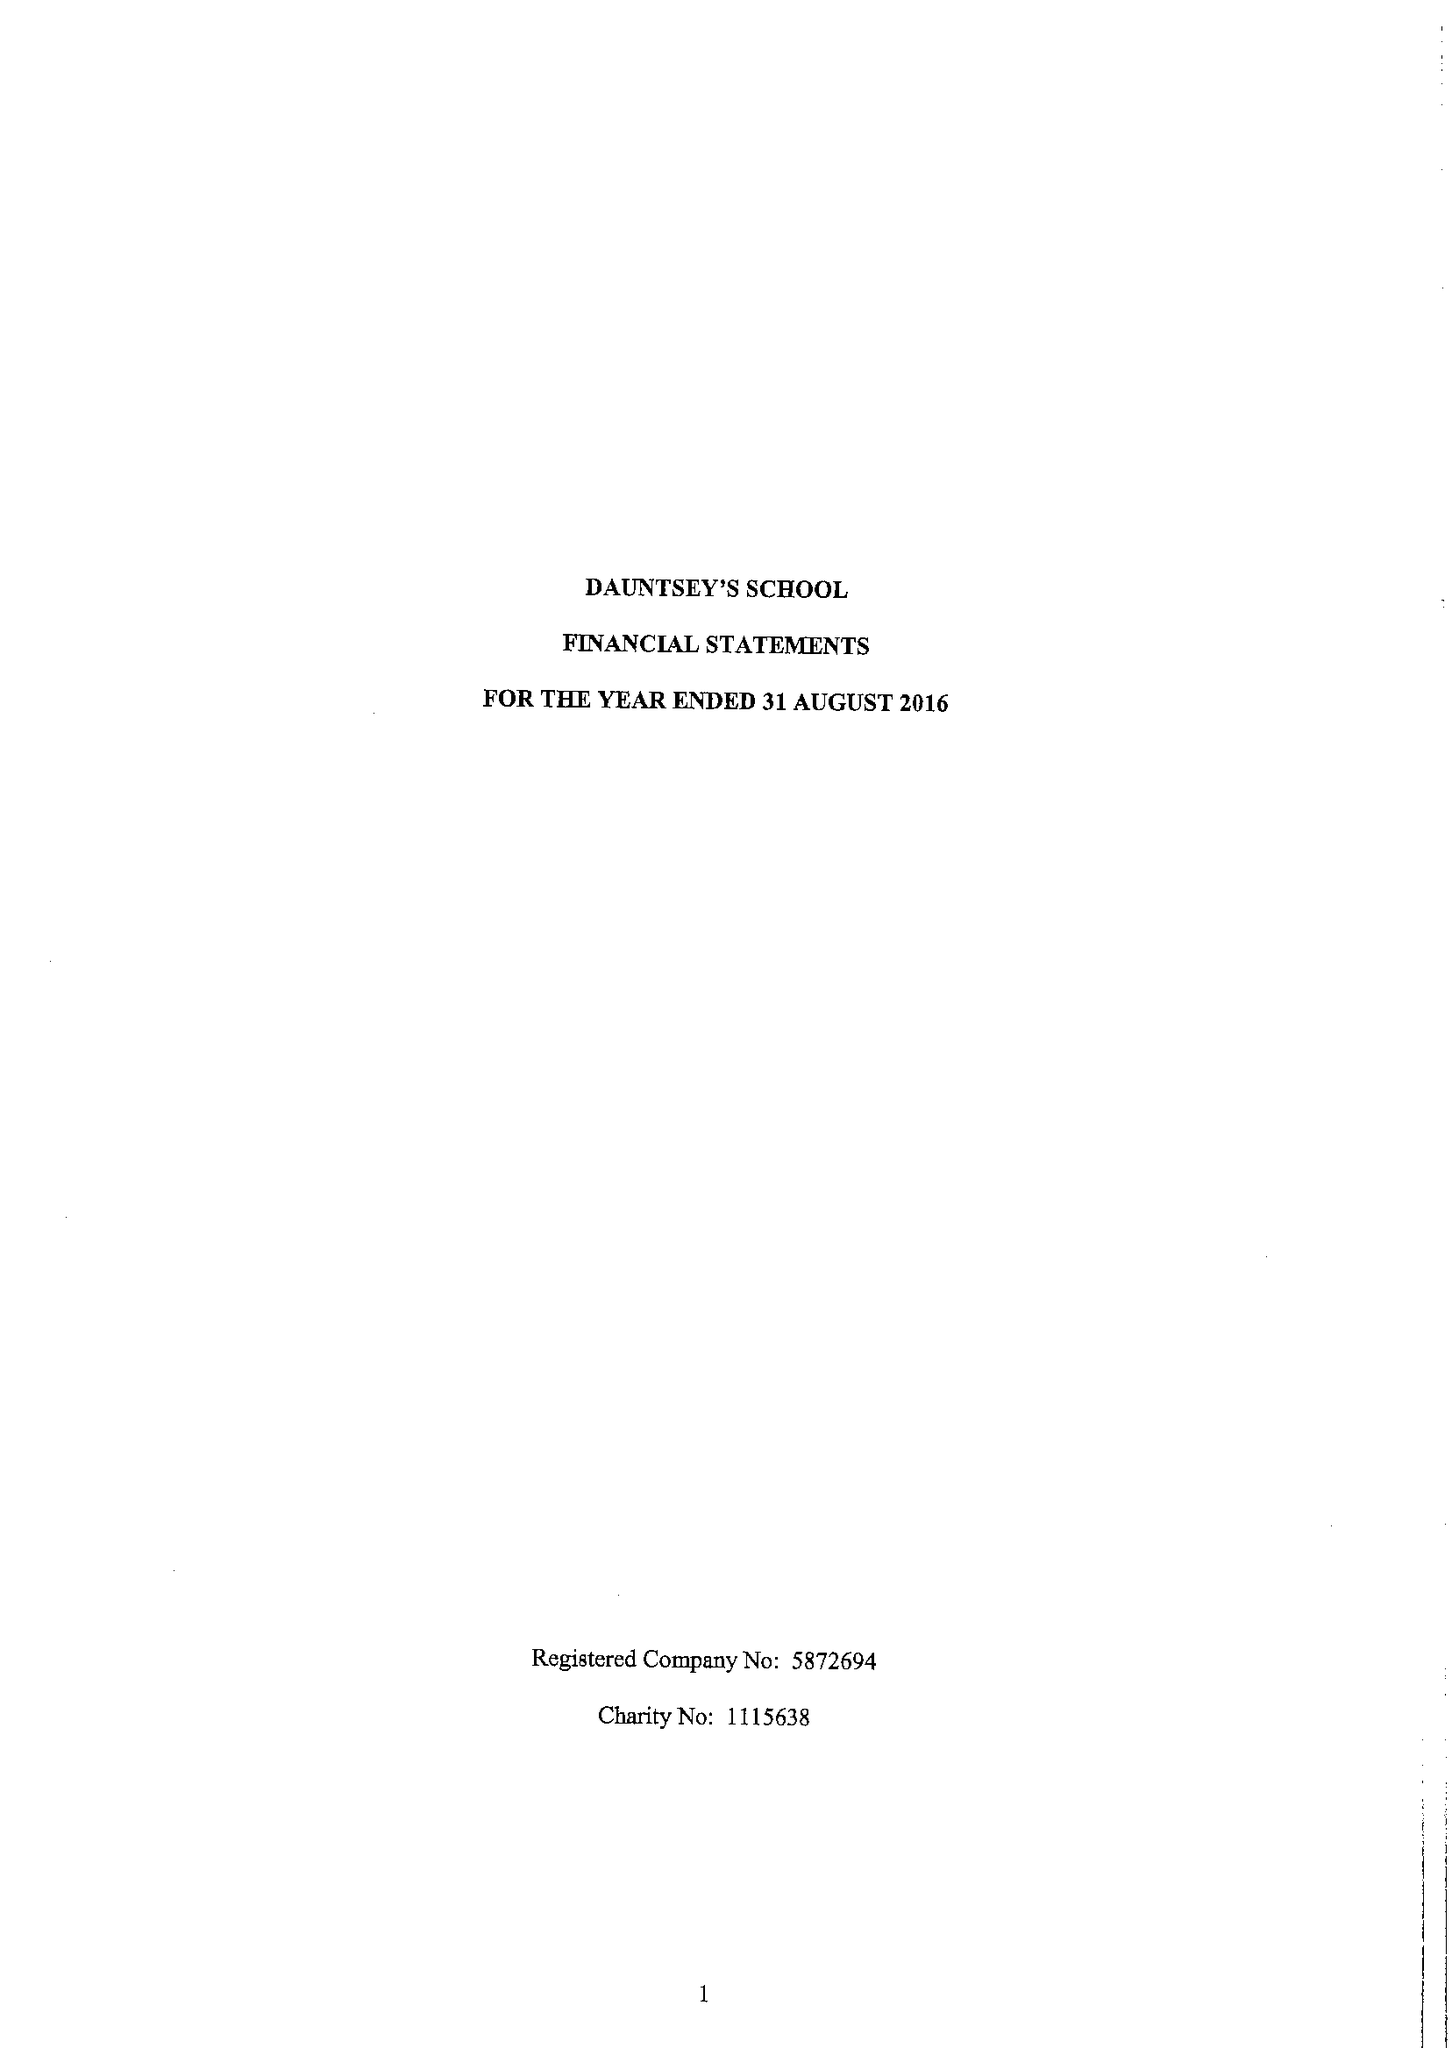What is the value for the charity_name?
Answer the question using a single word or phrase. Dauntsey's School 